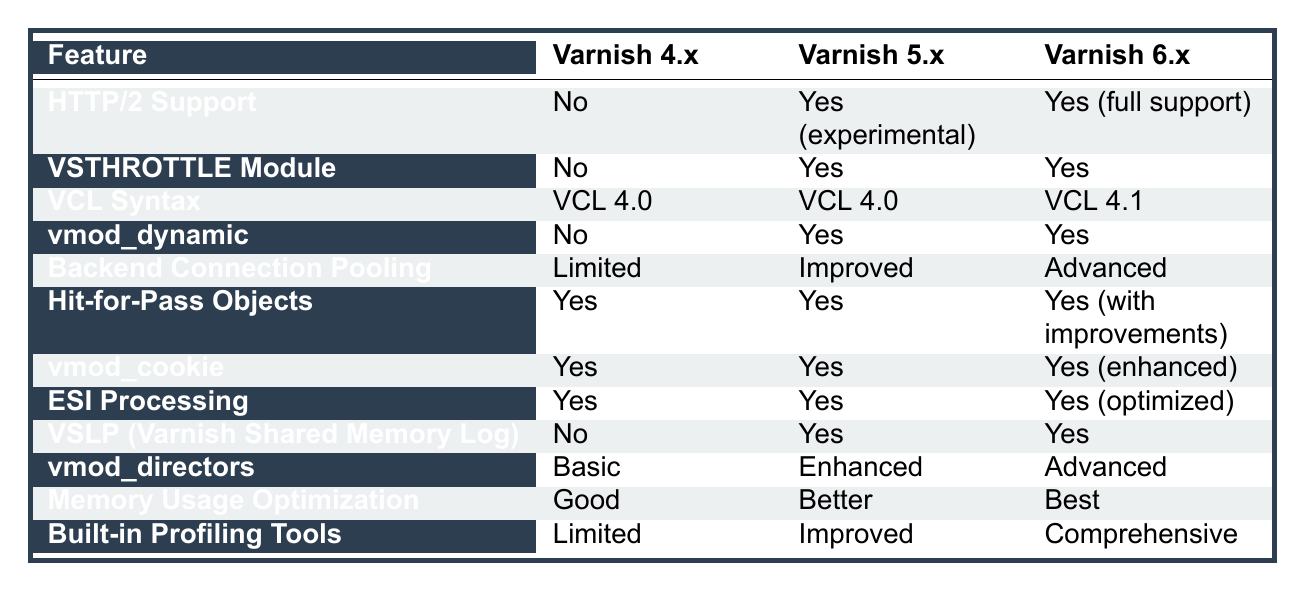What versions of Varnish Cache support HTTP/2? Varnish 4.x does not support HTTP/2, while Varnish 5.x has experimental support. However, Varnish 6.x offers full support for HTTP/2.
Answer: Varnish 5.x (experimental), Varnish 6.x (full support) Is there a VSTHROTTLE module available in Varnish 4.x? The table indicates that the VSTHROTTLE module is not available in Varnish 4.x, but it is available in both Varnish 5.x and 6.x.
Answer: No What is the difference in VCL Syntax between the three versions? Varnish 4.x and 5.x both use VCL 4.0, whereas Varnish 6.x uses an updated VCL 4.1.
Answer: Varnish 4.x and 5.x use VCL 4.0; Varnish 6.x uses VCL 4.1 How many versions support vmod_dynamic? Only Varnish 5.x and Varnish 6.x support vmod_dynamic, while Varnish 4.x does not, resulting in a total of 2 versions that support this feature.
Answer: 2 versions What improvements were made in backend connection pooling from Varnish 4.x to 6.x? The backend connection pooling in Varnish 4.x is limited, improved in 5.x, and advanced in 6.x. This indicates a significant enhancement in each version going forward.
Answer: From limited to improved to advanced Can vmod_cookie be considered enhanced in Varnish 6.x compared to Varnish 5.x? Yes, the table notes that while both Varnish 4.x and 5.x support vmod_cookie, Varnish 6.x provides enhanced support for it, indicating an improvement.
Answer: Yes Which version offers the best memory usage optimization? According to the table, Varnish 4.x has good memory optimization, 5.x has better, and 6.x has the best optimization among the three versions, making Varnish 6.x the most effective.
Answer: Varnish 6.x How does ESI processing compare across the three versions? ESI processing is available in all versions: it's the same in 4.x and 5.x and optimized in 6.x. Therefore, while the same feature exists in all versions, 6.x has enhancements.
Answer: Yes, optimized in 6.x Is there a significant change in built-in profiling tools from version 4.x to 6.x? Yes, there is a progression from limited profiling tools in Varnish 4.x to improved in 5.x and comprehensive in 6.x, indicating a significant enhancement across the versions.
Answer: Yes 